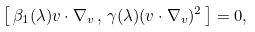<formula> <loc_0><loc_0><loc_500><loc_500>\left [ \, \beta _ { 1 } ( \lambda ) { v } \cdot \nabla _ { v } \, , \, \gamma ( \lambda ) ( { v } \cdot \nabla _ { v } ) ^ { 2 } \, \right ] = 0 ,</formula> 